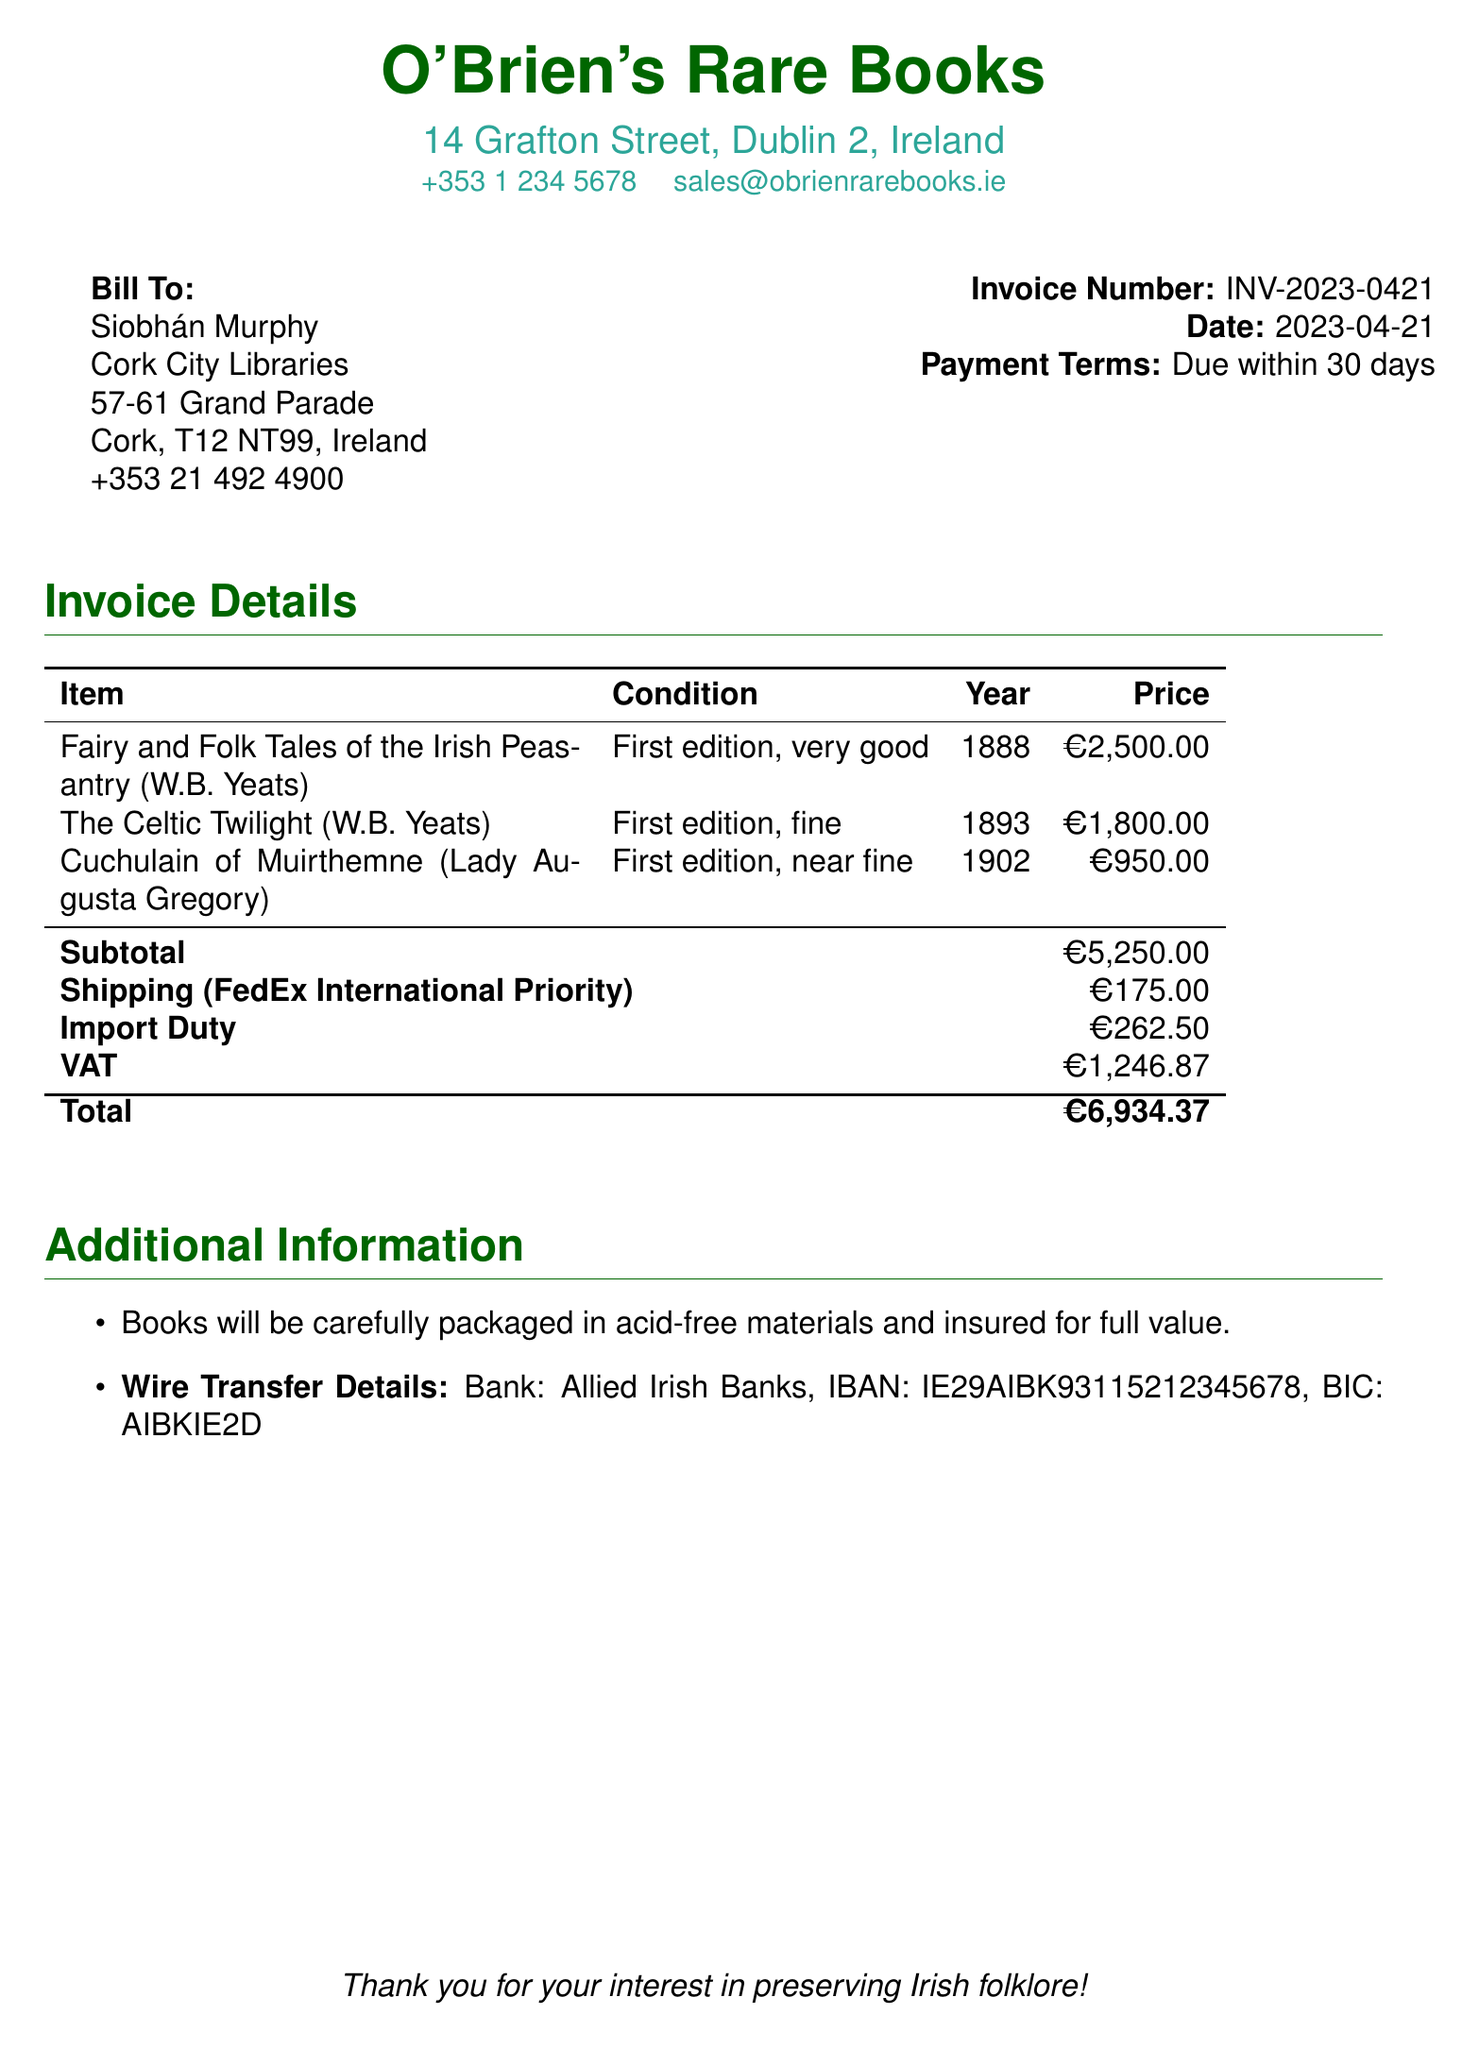What is the invoice number? The invoice number is specifically stated in the document for identification purposes.
Answer: INV-2023-0421 Who is the bill addressed to? The name of the individual or entity the bill is sent to is mentioned clearly in the document.
Answer: Siobhán Murphy What is the subtotal of the book purchases? The subtotal represents the total price of the items before any additional charges.
Answer: €5,250.00 What is the VAT amount? The VAT is listed separately in the invoice, indicating the tax applied to the total purchase.
Answer: €1,246.87 What is the total amount due? The total is a calculated figure that includes all charges and taxes listed in the invoice.
Answer: €6,934.37 Which shipping service is used? The specific shipping service utilized for delivery is indicated in the details of the invoice.
Answer: FedEx International Priority How many books are mentioned in the invoice? The number of distinct book titles listed provides insight into the items purchased.
Answer: 3 What is the condition of "Cuchulain of Muirthemne"? The condition of each item is described to inform the buyer about the quality of the book.
Answer: near fine What date is the invoice issued? The invoice date is an important detail for payment terms and processing.
Answer: 2023-04-21 